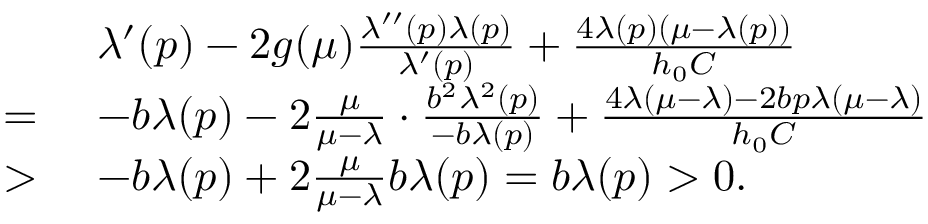<formula> <loc_0><loc_0><loc_500><loc_500>\begin{array} { r l } & { \lambda ^ { \prime } ( p ) - 2 g ( \mu ) \frac { \lambda ^ { \prime \prime } ( p ) \lambda ( p ) } { \lambda ^ { \prime } ( p ) } + \frac { 4 \lambda ( p ) ( \mu - \lambda ( p ) ) } { h _ { 0 } C } } \\ { = } & { - b \lambda ( p ) - 2 \frac { \mu } { \mu - \lambda } \cdot \frac { b ^ { 2 } \lambda ^ { 2 } ( p ) } { - b \lambda ( p ) } + \frac { 4 \lambda ( \mu - \lambda ) - 2 b p \lambda ( \mu - \lambda ) } { h _ { 0 } C } } \\ { > } & { - b \lambda ( p ) + 2 \frac { \mu } { \mu - \lambda } b \lambda ( p ) = b \lambda ( p ) > 0 . } \end{array}</formula> 